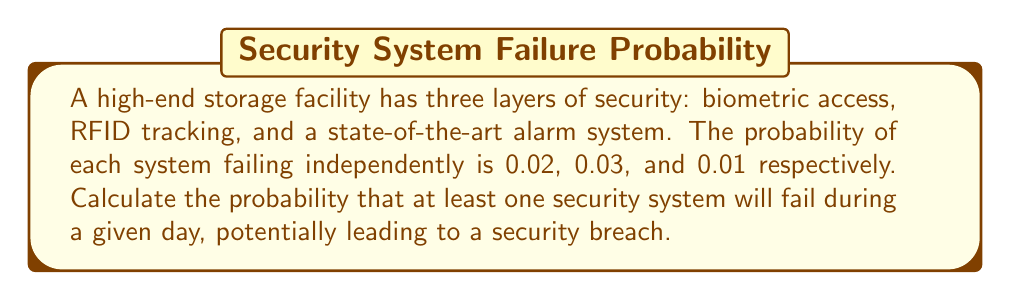Can you answer this question? To solve this problem, we'll use the concept of probability of the complement event.

Let's define the events:
$A$: Biometric access fails
$B$: RFID tracking fails
$C$: Alarm system fails

Given:
$P(A) = 0.02$
$P(B) = 0.03$
$P(C) = 0.01$

We want to find the probability that at least one system fails. This is equivalent to 1 minus the probability that all systems work correctly.

Step 1: Calculate the probability that each system works correctly:
$P(\text{A works}) = 1 - P(A) = 1 - 0.02 = 0.98$
$P(\text{B works}) = 1 - P(B) = 1 - 0.03 = 0.97$
$P(\text{C works}) = 1 - P(C) = 1 - 0.01 = 0.99$

Step 2: Calculate the probability that all systems work correctly:
$P(\text{all work}) = P(\text{A works}) \times P(\text{B works}) \times P(\text{C works})$
$P(\text{all work}) = 0.98 \times 0.97 \times 0.99 = 0.940698$

Step 3: Calculate the probability that at least one system fails:
$P(\text{at least one fails}) = 1 - P(\text{all work})$
$P(\text{at least one fails}) = 1 - 0.940698 = 0.059302$

Therefore, the probability of a potential security breach (at least one system failing) is approximately 0.059302 or 5.9302%.
Answer: $0.059302$ or $5.9302\%$ 